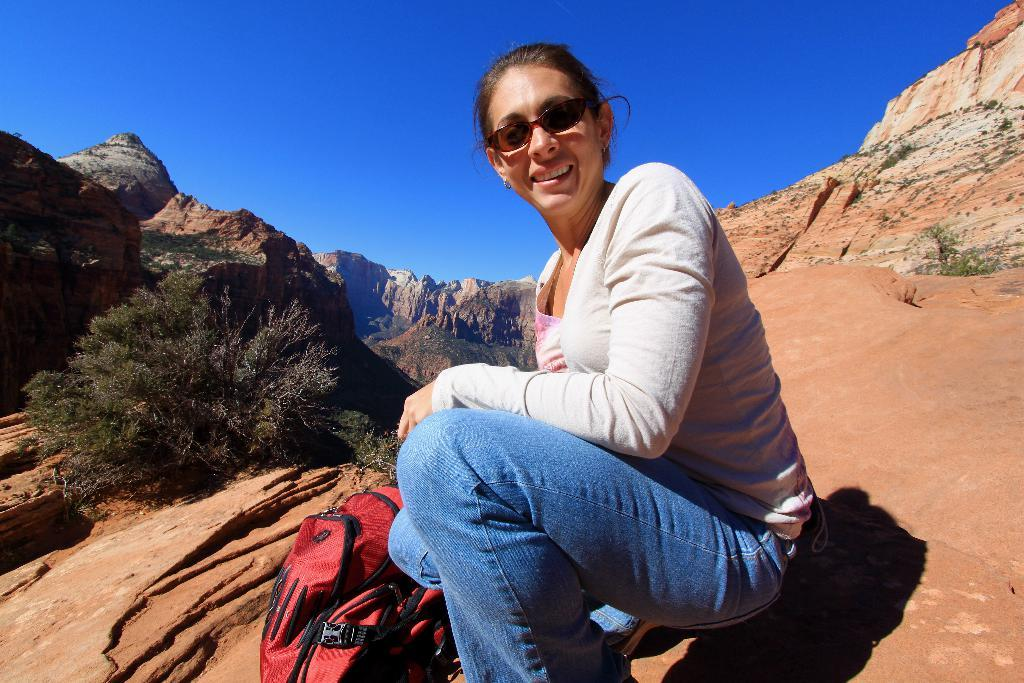What is the woman in the image doing? The woman is sitting in the image. What is the woman's facial expression? The woman is smiling. What object can be seen in the image besides the woman? There is a bag in the image. What type of natural scenery is visible in the image? There are trees and hills in the image. What can be seen in the background of the image? The sky is visible in the background of the image. What type of skate is the woman using to move around in the image? There is no skate present in the image, and the woman is sitting, not moving around. What advice is the woman giving to the trees in the image? There is no indication in the image that the woman is giving advice to the trees, as trees do not have the ability to receive or understand advice. 